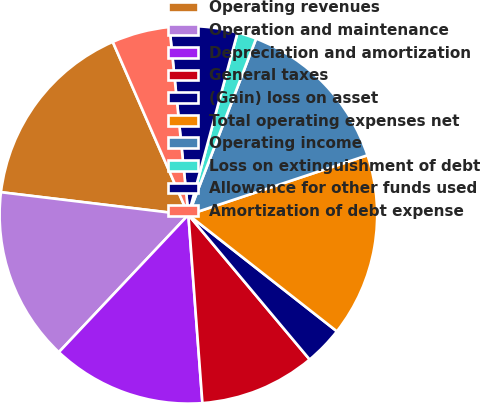Convert chart to OTSL. <chart><loc_0><loc_0><loc_500><loc_500><pie_chart><fcel>Operating revenues<fcel>Operation and maintenance<fcel>Depreciation and amortization<fcel>General taxes<fcel>(Gain) loss on asset<fcel>Total operating expenses net<fcel>Operating income<fcel>Loss on extinguishment of debt<fcel>Allowance for other funds used<fcel>Amortization of debt expense<nl><fcel>16.53%<fcel>14.88%<fcel>13.22%<fcel>9.92%<fcel>3.31%<fcel>15.7%<fcel>14.05%<fcel>1.65%<fcel>5.79%<fcel>4.96%<nl></chart> 